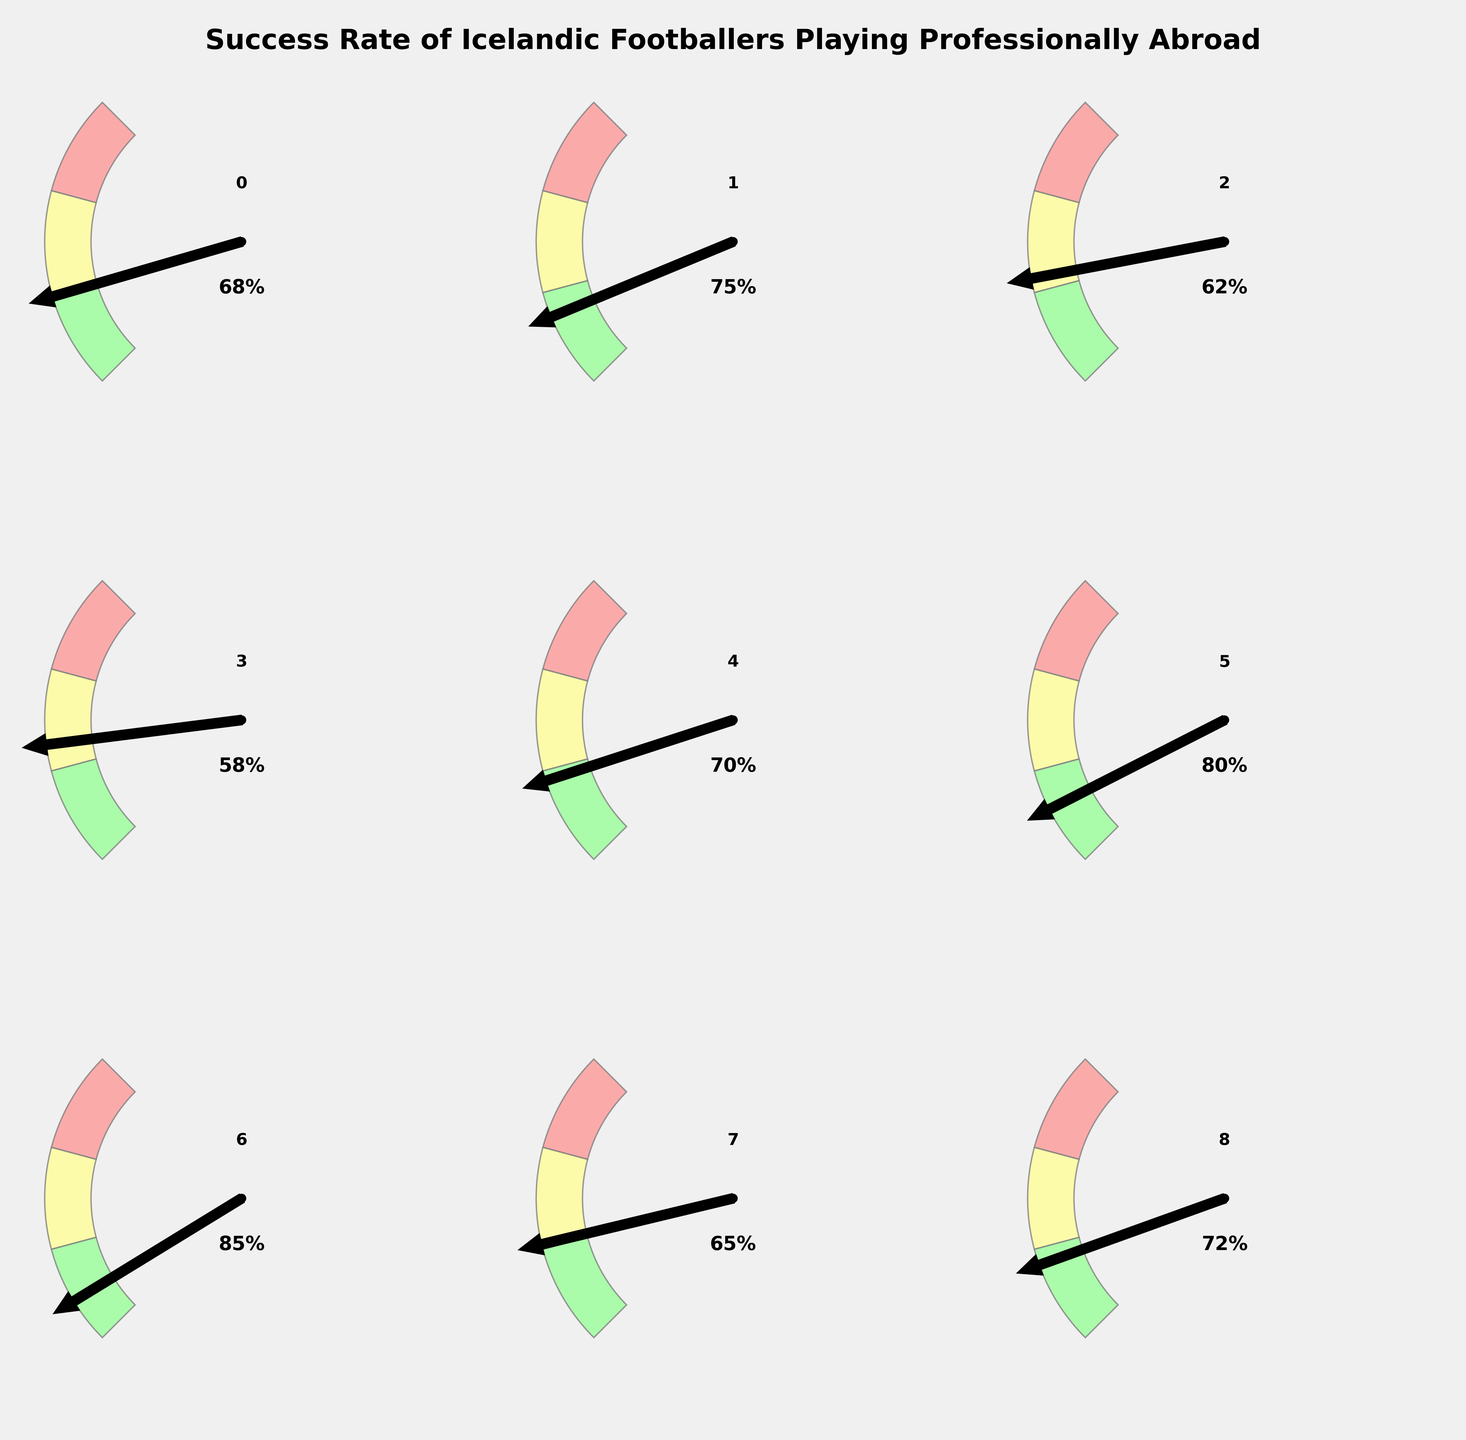What's the overall success rate of Icelandic footballers playing professionally abroad? The overall success rate is given right at the top of the data list and represented in one of the gauge charts. It shows the general performance of all Icelandic footballers playing abroad.
Answer: 68% Which league boasts the highest success rate for Icelandic footballers? By comparing the success rates displayed on the gauge charts, the Eredivisie has the highest value at 80%.
Answer: Eredivisie Between the Bundesliga and Ligue 1, which league has a higher success rate? Comparing the two success rates on the gauge charts, Bundesliga has a success rate of 62%, while Ligue 1 has 70%. Therefore, Ligue 1 has a higher success rate.
Answer: Ligue 1 What is the difference in success rate between the Serie A and the Premier League? The Serie A success rate is 58%, while the Premier League success rate is 75%. The difference is calculated as 75 - 58.
Answer: 17% How does the success rate in Scandinavian leagues compare to the overall success rate? The success rate in Scandinavian leagues is 85%, while the overall success rate is 68%. Comparing these values, the success rate in Scandinavian leagues is higher.
Answer: Higher What's the median success rate of the listed leagues? To find the median, first list the success rates in ascending order: 58, 62, 65, 68, 70, 72, 75, 80, 85. The median is the middle value in this ordered list, which is 70.
Answer: 70 Are there any leagues where the success rate is below 60%? Yes, the Serie A is the only league with a success rate below 60%, specifically at 58%.
Answer: Yes Which league has a success rate closest to the overall success rate? The overall success rate is 68%. Comparing all league success rates, the 'Other European Leagues' with 65% is the closest to 68%.
Answer: Other European Leagues Calculate the average success rate of all the leagues listed (excluding overall success rate). Adding the success rates of all leagues: 75 + 62 + 58 + 70 + 80 + 85 + 65 + 72 = 567. There are 8 leagues, so the average is 567 / 8.
Answer: 70.88 If the success rate for Eredivisie decreased by 5%, would it still have the highest success rate among all leagues? The current success rate for Eredivisie is 80%. If it decreases by 5%, it becomes 75%. Comparing this new value with all the other success rates: Premier League also has 75%, so Eredivisie would share the highest success rate with the Premier League.
Answer: Yes 